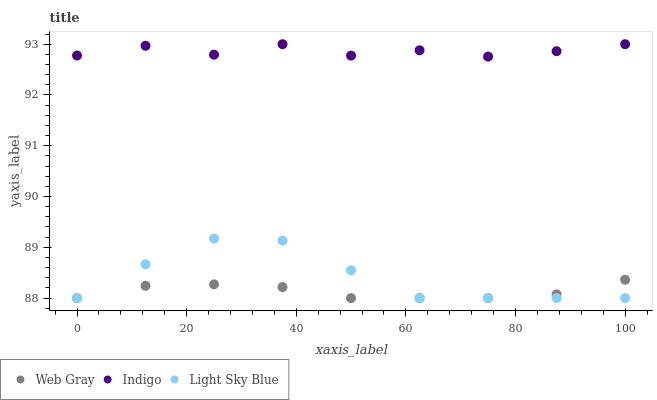Does Web Gray have the minimum area under the curve?
Answer yes or no. Yes. Does Indigo have the maximum area under the curve?
Answer yes or no. Yes. Does Light Sky Blue have the minimum area under the curve?
Answer yes or no. No. Does Light Sky Blue have the maximum area under the curve?
Answer yes or no. No. Is Web Gray the smoothest?
Answer yes or no. Yes. Is Indigo the roughest?
Answer yes or no. Yes. Is Light Sky Blue the smoothest?
Answer yes or no. No. Is Light Sky Blue the roughest?
Answer yes or no. No. Does Web Gray have the lowest value?
Answer yes or no. Yes. Does Indigo have the lowest value?
Answer yes or no. No. Does Indigo have the highest value?
Answer yes or no. Yes. Does Light Sky Blue have the highest value?
Answer yes or no. No. Is Light Sky Blue less than Indigo?
Answer yes or no. Yes. Is Indigo greater than Web Gray?
Answer yes or no. Yes. Does Web Gray intersect Light Sky Blue?
Answer yes or no. Yes. Is Web Gray less than Light Sky Blue?
Answer yes or no. No. Is Web Gray greater than Light Sky Blue?
Answer yes or no. No. Does Light Sky Blue intersect Indigo?
Answer yes or no. No. 